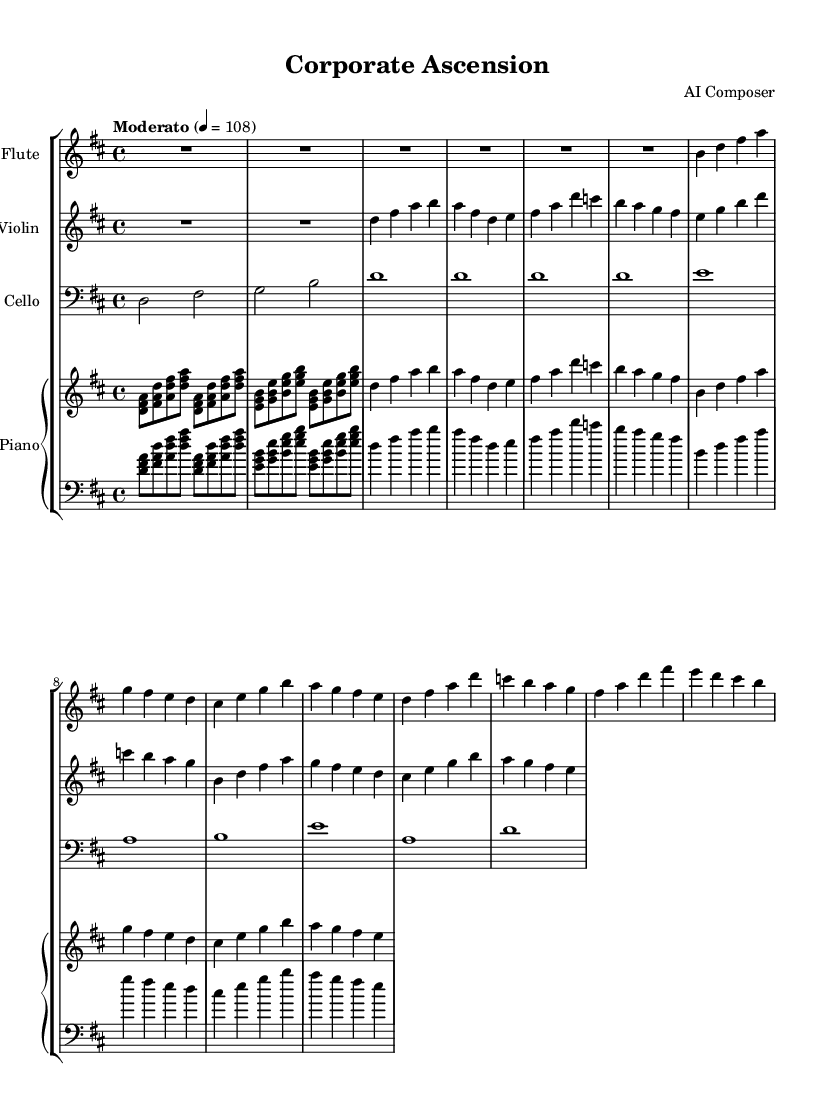What is the key signature of this music? The key signature shows two sharps (F# and C#) indicating it is in D major. This can be identified at the beginning of the staff where the sharps are placed.
Answer: D major What is the time signature of this piece? The time signature displays a "4/4" which means there are four beats in each measure and the quarter note receives one beat. This is found at the beginning of the score, typically before the key signature.
Answer: 4/4 What is the tempo marking for this composition? The tempo is marked as "Moderato," with a metronome mark indicating 108 beats per minute. This can be observed in the tempo indication at the start of the piece.
Answer: Moderato, 108 How many measures are in Theme A? By counting the number of measures specifically listed under Theme A, we can see that there are six measures total. This can be determined by counting each individual measure in the piano and violin parts corresponding to Theme A.
Answer: six Which instrument plays the introduction? The introduction is initially played by the piano, as indicated by the notation under the piano staff sections, where the first part is only attributed to the piano.
Answer: Piano How does Theme B differ from Theme A in terms of rhythmic complexity? Theme B incorporates a more varied rhythm compared to the steady quarter notes in Theme A. Analyzing the rhythmic patterns reveals that Theme B features both quarter and eighth notes, indicating a more complex rhythm than Theme A, which mainly consists of quarter notes.
Answer: More varied rhythm What is the range of the cello's part in this piece? The cello part spans from D in the bass clef up to A in the bass clef. By looking at the notes in the cello staff and identifying the highest and lowest notes, we establish that this is the range represented in the sheet music.
Answer: D to A 